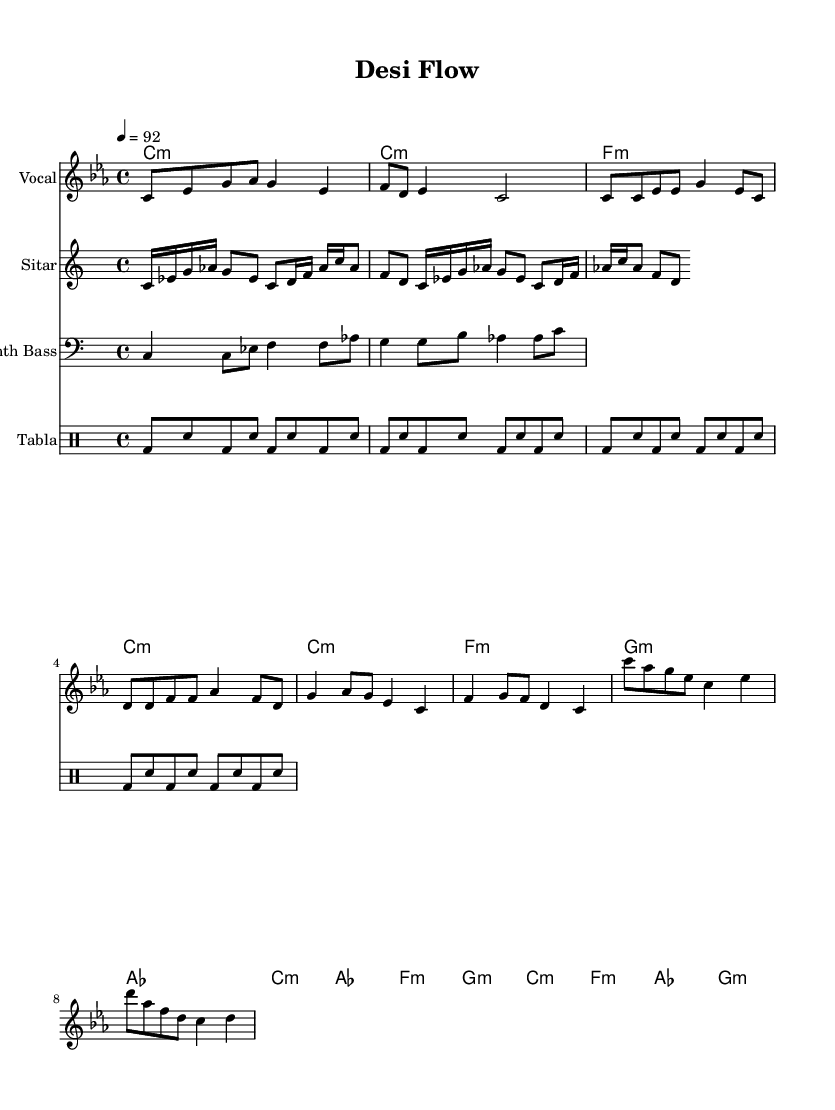What is the key signature of this music? The key signature is C minor, which is indicated by the two flat symbols shown on the staff.
Answer: C minor What is the time signature of this music? The time signature is 4/4, as indicated by the numbers at the beginning of the score, allowing for four beats per measure.
Answer: 4/4 What is the tempo marking for this piece? The tempo marking is 92 beats per minute, which is specified at the start of the score and indicates the speed of the music.
Answer: 92 How many measures are in the verse section? The verse section contains four measures, which can be identified by counting the sequence of bars designated as the verse in the melody.
Answer: 4 What instrument plays the rhythmic foundation in this piece? The tabla provides the rhythmic foundation, confirmed by the specially notated drum staff containing the tabla pattern.
Answer: Tabla Which section contains the highest pitch in the melody? The bridge section contains the highest pitch, as the melody notates a higher note sequence compared to other sections.
Answer: Bridge How many different instruments are included in this score? There are four different instruments included in this score: Vocal, Sitar, Synth Bass, and Tabla, as noted at the beginning of each staff.
Answer: Four 